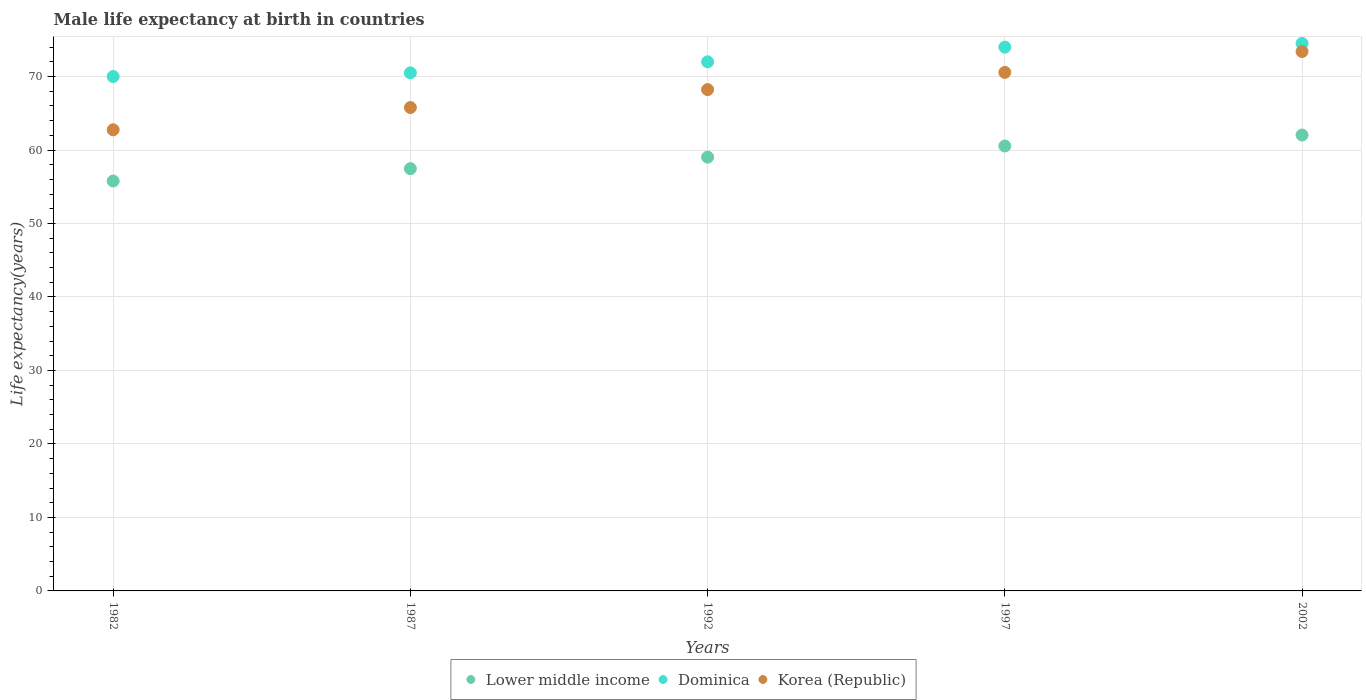How many different coloured dotlines are there?
Keep it short and to the point. 3. Is the number of dotlines equal to the number of legend labels?
Your answer should be very brief. Yes. What is the male life expectancy at birth in Korea (Republic) in 1992?
Provide a short and direct response. 68.22. Across all years, what is the maximum male life expectancy at birth in Korea (Republic)?
Offer a very short reply. 73.4. What is the total male life expectancy at birth in Lower middle income in the graph?
Provide a short and direct response. 294.86. What is the difference between the male life expectancy at birth in Dominica in 1982 and that in 2002?
Provide a succinct answer. -4.5. What is the difference between the male life expectancy at birth in Dominica in 1992 and the male life expectancy at birth in Lower middle income in 1997?
Provide a short and direct response. 11.45. What is the average male life expectancy at birth in Lower middle income per year?
Provide a short and direct response. 58.97. In the year 1982, what is the difference between the male life expectancy at birth in Dominica and male life expectancy at birth in Lower middle income?
Give a very brief answer. 14.22. What is the ratio of the male life expectancy at birth in Korea (Republic) in 1982 to that in 1992?
Offer a very short reply. 0.92. Is the male life expectancy at birth in Dominica in 1982 less than that in 1997?
Your answer should be very brief. Yes. Is the difference between the male life expectancy at birth in Dominica in 1992 and 2002 greater than the difference between the male life expectancy at birth in Lower middle income in 1992 and 2002?
Offer a terse response. Yes. What is the difference between the highest and the second highest male life expectancy at birth in Korea (Republic)?
Offer a terse response. 2.84. What is the difference between the highest and the lowest male life expectancy at birth in Lower middle income?
Give a very brief answer. 6.26. In how many years, is the male life expectancy at birth in Korea (Republic) greater than the average male life expectancy at birth in Korea (Republic) taken over all years?
Ensure brevity in your answer.  3. Is the sum of the male life expectancy at birth in Lower middle income in 1982 and 1987 greater than the maximum male life expectancy at birth in Dominica across all years?
Provide a short and direct response. Yes. Is it the case that in every year, the sum of the male life expectancy at birth in Korea (Republic) and male life expectancy at birth in Lower middle income  is greater than the male life expectancy at birth in Dominica?
Your answer should be compact. Yes. Does the male life expectancy at birth in Korea (Republic) monotonically increase over the years?
Your answer should be very brief. Yes. Is the male life expectancy at birth in Dominica strictly less than the male life expectancy at birth in Korea (Republic) over the years?
Your response must be concise. No. How many years are there in the graph?
Give a very brief answer. 5. Does the graph contain any zero values?
Offer a very short reply. No. Does the graph contain grids?
Your answer should be compact. Yes. Where does the legend appear in the graph?
Your response must be concise. Bottom center. How are the legend labels stacked?
Keep it short and to the point. Horizontal. What is the title of the graph?
Your answer should be compact. Male life expectancy at birth in countries. What is the label or title of the X-axis?
Your response must be concise. Years. What is the label or title of the Y-axis?
Provide a short and direct response. Life expectancy(years). What is the Life expectancy(years) of Lower middle income in 1982?
Provide a short and direct response. 55.78. What is the Life expectancy(years) of Korea (Republic) in 1982?
Provide a short and direct response. 62.75. What is the Life expectancy(years) in Lower middle income in 1987?
Make the answer very short. 57.46. What is the Life expectancy(years) in Dominica in 1987?
Ensure brevity in your answer.  70.5. What is the Life expectancy(years) in Korea (Republic) in 1987?
Your answer should be compact. 65.78. What is the Life expectancy(years) of Lower middle income in 1992?
Ensure brevity in your answer.  59.03. What is the Life expectancy(years) of Korea (Republic) in 1992?
Offer a terse response. 68.22. What is the Life expectancy(years) of Lower middle income in 1997?
Offer a terse response. 60.55. What is the Life expectancy(years) of Dominica in 1997?
Provide a succinct answer. 74. What is the Life expectancy(years) of Korea (Republic) in 1997?
Your answer should be very brief. 70.56. What is the Life expectancy(years) in Lower middle income in 2002?
Offer a terse response. 62.04. What is the Life expectancy(years) in Dominica in 2002?
Give a very brief answer. 74.5. What is the Life expectancy(years) in Korea (Republic) in 2002?
Your response must be concise. 73.4. Across all years, what is the maximum Life expectancy(years) in Lower middle income?
Provide a short and direct response. 62.04. Across all years, what is the maximum Life expectancy(years) of Dominica?
Your response must be concise. 74.5. Across all years, what is the maximum Life expectancy(years) of Korea (Republic)?
Your answer should be compact. 73.4. Across all years, what is the minimum Life expectancy(years) in Lower middle income?
Offer a terse response. 55.78. Across all years, what is the minimum Life expectancy(years) in Korea (Republic)?
Ensure brevity in your answer.  62.75. What is the total Life expectancy(years) in Lower middle income in the graph?
Offer a very short reply. 294.86. What is the total Life expectancy(years) of Dominica in the graph?
Your answer should be very brief. 361. What is the total Life expectancy(years) in Korea (Republic) in the graph?
Your response must be concise. 340.71. What is the difference between the Life expectancy(years) of Lower middle income in 1982 and that in 1987?
Offer a very short reply. -1.68. What is the difference between the Life expectancy(years) of Dominica in 1982 and that in 1987?
Offer a terse response. -0.5. What is the difference between the Life expectancy(years) in Korea (Republic) in 1982 and that in 1987?
Make the answer very short. -3.03. What is the difference between the Life expectancy(years) of Lower middle income in 1982 and that in 1992?
Provide a short and direct response. -3.24. What is the difference between the Life expectancy(years) in Korea (Republic) in 1982 and that in 1992?
Provide a short and direct response. -5.47. What is the difference between the Life expectancy(years) in Lower middle income in 1982 and that in 1997?
Provide a succinct answer. -4.76. What is the difference between the Life expectancy(years) of Korea (Republic) in 1982 and that in 1997?
Give a very brief answer. -7.81. What is the difference between the Life expectancy(years) of Lower middle income in 1982 and that in 2002?
Provide a succinct answer. -6.26. What is the difference between the Life expectancy(years) in Dominica in 1982 and that in 2002?
Provide a succinct answer. -4.5. What is the difference between the Life expectancy(years) of Korea (Republic) in 1982 and that in 2002?
Offer a very short reply. -10.65. What is the difference between the Life expectancy(years) of Lower middle income in 1987 and that in 1992?
Keep it short and to the point. -1.56. What is the difference between the Life expectancy(years) in Dominica in 1987 and that in 1992?
Your answer should be compact. -1.5. What is the difference between the Life expectancy(years) of Korea (Republic) in 1987 and that in 1992?
Make the answer very short. -2.44. What is the difference between the Life expectancy(years) of Lower middle income in 1987 and that in 1997?
Provide a succinct answer. -3.08. What is the difference between the Life expectancy(years) of Dominica in 1987 and that in 1997?
Offer a very short reply. -3.5. What is the difference between the Life expectancy(years) of Korea (Republic) in 1987 and that in 1997?
Your answer should be compact. -4.78. What is the difference between the Life expectancy(years) of Lower middle income in 1987 and that in 2002?
Provide a short and direct response. -4.58. What is the difference between the Life expectancy(years) of Dominica in 1987 and that in 2002?
Provide a succinct answer. -4. What is the difference between the Life expectancy(years) in Korea (Republic) in 1987 and that in 2002?
Give a very brief answer. -7.62. What is the difference between the Life expectancy(years) in Lower middle income in 1992 and that in 1997?
Offer a very short reply. -1.52. What is the difference between the Life expectancy(years) of Korea (Republic) in 1992 and that in 1997?
Offer a terse response. -2.34. What is the difference between the Life expectancy(years) of Lower middle income in 1992 and that in 2002?
Your response must be concise. -3.01. What is the difference between the Life expectancy(years) in Dominica in 1992 and that in 2002?
Ensure brevity in your answer.  -2.5. What is the difference between the Life expectancy(years) of Korea (Republic) in 1992 and that in 2002?
Your answer should be compact. -5.18. What is the difference between the Life expectancy(years) of Lower middle income in 1997 and that in 2002?
Provide a succinct answer. -1.5. What is the difference between the Life expectancy(years) of Dominica in 1997 and that in 2002?
Ensure brevity in your answer.  -0.5. What is the difference between the Life expectancy(years) of Korea (Republic) in 1997 and that in 2002?
Offer a very short reply. -2.84. What is the difference between the Life expectancy(years) in Lower middle income in 1982 and the Life expectancy(years) in Dominica in 1987?
Provide a short and direct response. -14.72. What is the difference between the Life expectancy(years) of Lower middle income in 1982 and the Life expectancy(years) of Korea (Republic) in 1987?
Ensure brevity in your answer.  -10. What is the difference between the Life expectancy(years) of Dominica in 1982 and the Life expectancy(years) of Korea (Republic) in 1987?
Your response must be concise. 4.22. What is the difference between the Life expectancy(years) of Lower middle income in 1982 and the Life expectancy(years) of Dominica in 1992?
Ensure brevity in your answer.  -16.22. What is the difference between the Life expectancy(years) in Lower middle income in 1982 and the Life expectancy(years) in Korea (Republic) in 1992?
Offer a terse response. -12.44. What is the difference between the Life expectancy(years) in Dominica in 1982 and the Life expectancy(years) in Korea (Republic) in 1992?
Ensure brevity in your answer.  1.78. What is the difference between the Life expectancy(years) of Lower middle income in 1982 and the Life expectancy(years) of Dominica in 1997?
Ensure brevity in your answer.  -18.22. What is the difference between the Life expectancy(years) of Lower middle income in 1982 and the Life expectancy(years) of Korea (Republic) in 1997?
Keep it short and to the point. -14.78. What is the difference between the Life expectancy(years) in Dominica in 1982 and the Life expectancy(years) in Korea (Republic) in 1997?
Offer a very short reply. -0.56. What is the difference between the Life expectancy(years) in Lower middle income in 1982 and the Life expectancy(years) in Dominica in 2002?
Provide a short and direct response. -18.72. What is the difference between the Life expectancy(years) in Lower middle income in 1982 and the Life expectancy(years) in Korea (Republic) in 2002?
Your answer should be very brief. -17.62. What is the difference between the Life expectancy(years) in Lower middle income in 1987 and the Life expectancy(years) in Dominica in 1992?
Keep it short and to the point. -14.54. What is the difference between the Life expectancy(years) of Lower middle income in 1987 and the Life expectancy(years) of Korea (Republic) in 1992?
Give a very brief answer. -10.76. What is the difference between the Life expectancy(years) in Dominica in 1987 and the Life expectancy(years) in Korea (Republic) in 1992?
Your response must be concise. 2.28. What is the difference between the Life expectancy(years) in Lower middle income in 1987 and the Life expectancy(years) in Dominica in 1997?
Offer a very short reply. -16.54. What is the difference between the Life expectancy(years) of Lower middle income in 1987 and the Life expectancy(years) of Korea (Republic) in 1997?
Your answer should be very brief. -13.1. What is the difference between the Life expectancy(years) in Dominica in 1987 and the Life expectancy(years) in Korea (Republic) in 1997?
Ensure brevity in your answer.  -0.06. What is the difference between the Life expectancy(years) in Lower middle income in 1987 and the Life expectancy(years) in Dominica in 2002?
Make the answer very short. -17.04. What is the difference between the Life expectancy(years) of Lower middle income in 1987 and the Life expectancy(years) of Korea (Republic) in 2002?
Your answer should be compact. -15.94. What is the difference between the Life expectancy(years) in Dominica in 1987 and the Life expectancy(years) in Korea (Republic) in 2002?
Give a very brief answer. -2.9. What is the difference between the Life expectancy(years) of Lower middle income in 1992 and the Life expectancy(years) of Dominica in 1997?
Your response must be concise. -14.97. What is the difference between the Life expectancy(years) of Lower middle income in 1992 and the Life expectancy(years) of Korea (Republic) in 1997?
Make the answer very short. -11.53. What is the difference between the Life expectancy(years) of Dominica in 1992 and the Life expectancy(years) of Korea (Republic) in 1997?
Your answer should be very brief. 1.44. What is the difference between the Life expectancy(years) of Lower middle income in 1992 and the Life expectancy(years) of Dominica in 2002?
Provide a succinct answer. -15.47. What is the difference between the Life expectancy(years) of Lower middle income in 1992 and the Life expectancy(years) of Korea (Republic) in 2002?
Provide a succinct answer. -14.37. What is the difference between the Life expectancy(years) in Dominica in 1992 and the Life expectancy(years) in Korea (Republic) in 2002?
Keep it short and to the point. -1.4. What is the difference between the Life expectancy(years) of Lower middle income in 1997 and the Life expectancy(years) of Dominica in 2002?
Make the answer very short. -13.95. What is the difference between the Life expectancy(years) of Lower middle income in 1997 and the Life expectancy(years) of Korea (Republic) in 2002?
Your response must be concise. -12.85. What is the average Life expectancy(years) in Lower middle income per year?
Your answer should be very brief. 58.97. What is the average Life expectancy(years) of Dominica per year?
Offer a terse response. 72.2. What is the average Life expectancy(years) in Korea (Republic) per year?
Keep it short and to the point. 68.14. In the year 1982, what is the difference between the Life expectancy(years) of Lower middle income and Life expectancy(years) of Dominica?
Make the answer very short. -14.22. In the year 1982, what is the difference between the Life expectancy(years) in Lower middle income and Life expectancy(years) in Korea (Republic)?
Offer a very short reply. -6.97. In the year 1982, what is the difference between the Life expectancy(years) in Dominica and Life expectancy(years) in Korea (Republic)?
Ensure brevity in your answer.  7.25. In the year 1987, what is the difference between the Life expectancy(years) in Lower middle income and Life expectancy(years) in Dominica?
Keep it short and to the point. -13.04. In the year 1987, what is the difference between the Life expectancy(years) in Lower middle income and Life expectancy(years) in Korea (Republic)?
Give a very brief answer. -8.32. In the year 1987, what is the difference between the Life expectancy(years) in Dominica and Life expectancy(years) in Korea (Republic)?
Give a very brief answer. 4.72. In the year 1992, what is the difference between the Life expectancy(years) of Lower middle income and Life expectancy(years) of Dominica?
Your answer should be compact. -12.97. In the year 1992, what is the difference between the Life expectancy(years) of Lower middle income and Life expectancy(years) of Korea (Republic)?
Your answer should be very brief. -9.19. In the year 1992, what is the difference between the Life expectancy(years) of Dominica and Life expectancy(years) of Korea (Republic)?
Provide a succinct answer. 3.78. In the year 1997, what is the difference between the Life expectancy(years) of Lower middle income and Life expectancy(years) of Dominica?
Ensure brevity in your answer.  -13.45. In the year 1997, what is the difference between the Life expectancy(years) of Lower middle income and Life expectancy(years) of Korea (Republic)?
Your response must be concise. -10.01. In the year 1997, what is the difference between the Life expectancy(years) of Dominica and Life expectancy(years) of Korea (Republic)?
Offer a very short reply. 3.44. In the year 2002, what is the difference between the Life expectancy(years) in Lower middle income and Life expectancy(years) in Dominica?
Provide a short and direct response. -12.46. In the year 2002, what is the difference between the Life expectancy(years) in Lower middle income and Life expectancy(years) in Korea (Republic)?
Ensure brevity in your answer.  -11.36. In the year 2002, what is the difference between the Life expectancy(years) of Dominica and Life expectancy(years) of Korea (Republic)?
Offer a terse response. 1.1. What is the ratio of the Life expectancy(years) in Lower middle income in 1982 to that in 1987?
Your answer should be compact. 0.97. What is the ratio of the Life expectancy(years) of Dominica in 1982 to that in 1987?
Offer a terse response. 0.99. What is the ratio of the Life expectancy(years) of Korea (Republic) in 1982 to that in 1987?
Your answer should be very brief. 0.95. What is the ratio of the Life expectancy(years) of Lower middle income in 1982 to that in 1992?
Keep it short and to the point. 0.94. What is the ratio of the Life expectancy(years) in Dominica in 1982 to that in 1992?
Make the answer very short. 0.97. What is the ratio of the Life expectancy(years) of Korea (Republic) in 1982 to that in 1992?
Give a very brief answer. 0.92. What is the ratio of the Life expectancy(years) of Lower middle income in 1982 to that in 1997?
Provide a short and direct response. 0.92. What is the ratio of the Life expectancy(years) of Dominica in 1982 to that in 1997?
Give a very brief answer. 0.95. What is the ratio of the Life expectancy(years) in Korea (Republic) in 1982 to that in 1997?
Your answer should be very brief. 0.89. What is the ratio of the Life expectancy(years) in Lower middle income in 1982 to that in 2002?
Ensure brevity in your answer.  0.9. What is the ratio of the Life expectancy(years) of Dominica in 1982 to that in 2002?
Provide a succinct answer. 0.94. What is the ratio of the Life expectancy(years) of Korea (Republic) in 1982 to that in 2002?
Your answer should be very brief. 0.85. What is the ratio of the Life expectancy(years) in Lower middle income in 1987 to that in 1992?
Make the answer very short. 0.97. What is the ratio of the Life expectancy(years) in Dominica in 1987 to that in 1992?
Keep it short and to the point. 0.98. What is the ratio of the Life expectancy(years) in Korea (Republic) in 1987 to that in 1992?
Make the answer very short. 0.96. What is the ratio of the Life expectancy(years) in Lower middle income in 1987 to that in 1997?
Ensure brevity in your answer.  0.95. What is the ratio of the Life expectancy(years) of Dominica in 1987 to that in 1997?
Your answer should be very brief. 0.95. What is the ratio of the Life expectancy(years) of Korea (Republic) in 1987 to that in 1997?
Your answer should be very brief. 0.93. What is the ratio of the Life expectancy(years) of Lower middle income in 1987 to that in 2002?
Keep it short and to the point. 0.93. What is the ratio of the Life expectancy(years) of Dominica in 1987 to that in 2002?
Ensure brevity in your answer.  0.95. What is the ratio of the Life expectancy(years) of Korea (Republic) in 1987 to that in 2002?
Your answer should be very brief. 0.9. What is the ratio of the Life expectancy(years) in Lower middle income in 1992 to that in 1997?
Ensure brevity in your answer.  0.97. What is the ratio of the Life expectancy(years) of Korea (Republic) in 1992 to that in 1997?
Give a very brief answer. 0.97. What is the ratio of the Life expectancy(years) in Lower middle income in 1992 to that in 2002?
Make the answer very short. 0.95. What is the ratio of the Life expectancy(years) of Dominica in 1992 to that in 2002?
Your response must be concise. 0.97. What is the ratio of the Life expectancy(years) in Korea (Republic) in 1992 to that in 2002?
Your response must be concise. 0.93. What is the ratio of the Life expectancy(years) in Lower middle income in 1997 to that in 2002?
Provide a short and direct response. 0.98. What is the ratio of the Life expectancy(years) in Dominica in 1997 to that in 2002?
Offer a terse response. 0.99. What is the ratio of the Life expectancy(years) of Korea (Republic) in 1997 to that in 2002?
Your answer should be compact. 0.96. What is the difference between the highest and the second highest Life expectancy(years) in Lower middle income?
Provide a short and direct response. 1.5. What is the difference between the highest and the second highest Life expectancy(years) in Korea (Republic)?
Ensure brevity in your answer.  2.84. What is the difference between the highest and the lowest Life expectancy(years) in Lower middle income?
Provide a succinct answer. 6.26. What is the difference between the highest and the lowest Life expectancy(years) of Dominica?
Ensure brevity in your answer.  4.5. What is the difference between the highest and the lowest Life expectancy(years) of Korea (Republic)?
Your response must be concise. 10.65. 